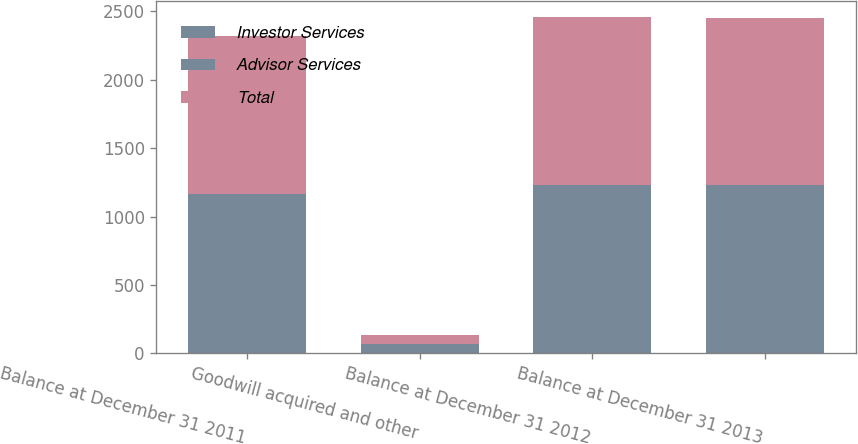Convert chart to OTSL. <chart><loc_0><loc_0><loc_500><loc_500><stacked_bar_chart><ecel><fcel>Balance at December 31 2011<fcel>Goodwill acquired and other<fcel>Balance at December 31 2012<fcel>Balance at December 31 2013<nl><fcel>Investor Services<fcel>1083<fcel>45<fcel>1128<fcel>1127<nl><fcel>Advisor Services<fcel>78<fcel>22<fcel>100<fcel>100<nl><fcel>Total<fcel>1161<fcel>67<fcel>1228<fcel>1227<nl></chart> 